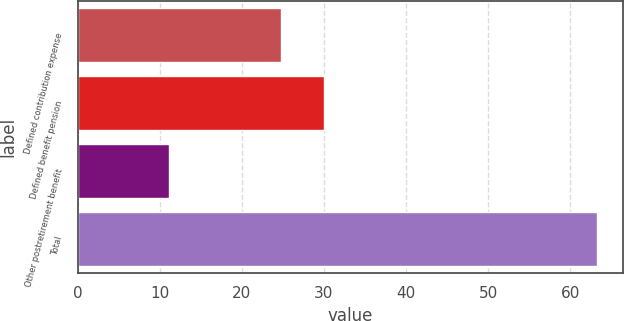Convert chart to OTSL. <chart><loc_0><loc_0><loc_500><loc_500><bar_chart><fcel>Defined contribution expense<fcel>Defined benefit pension<fcel>Other postretirement benefit<fcel>Total<nl><fcel>24.8<fcel>30.01<fcel>11.1<fcel>63.2<nl></chart> 